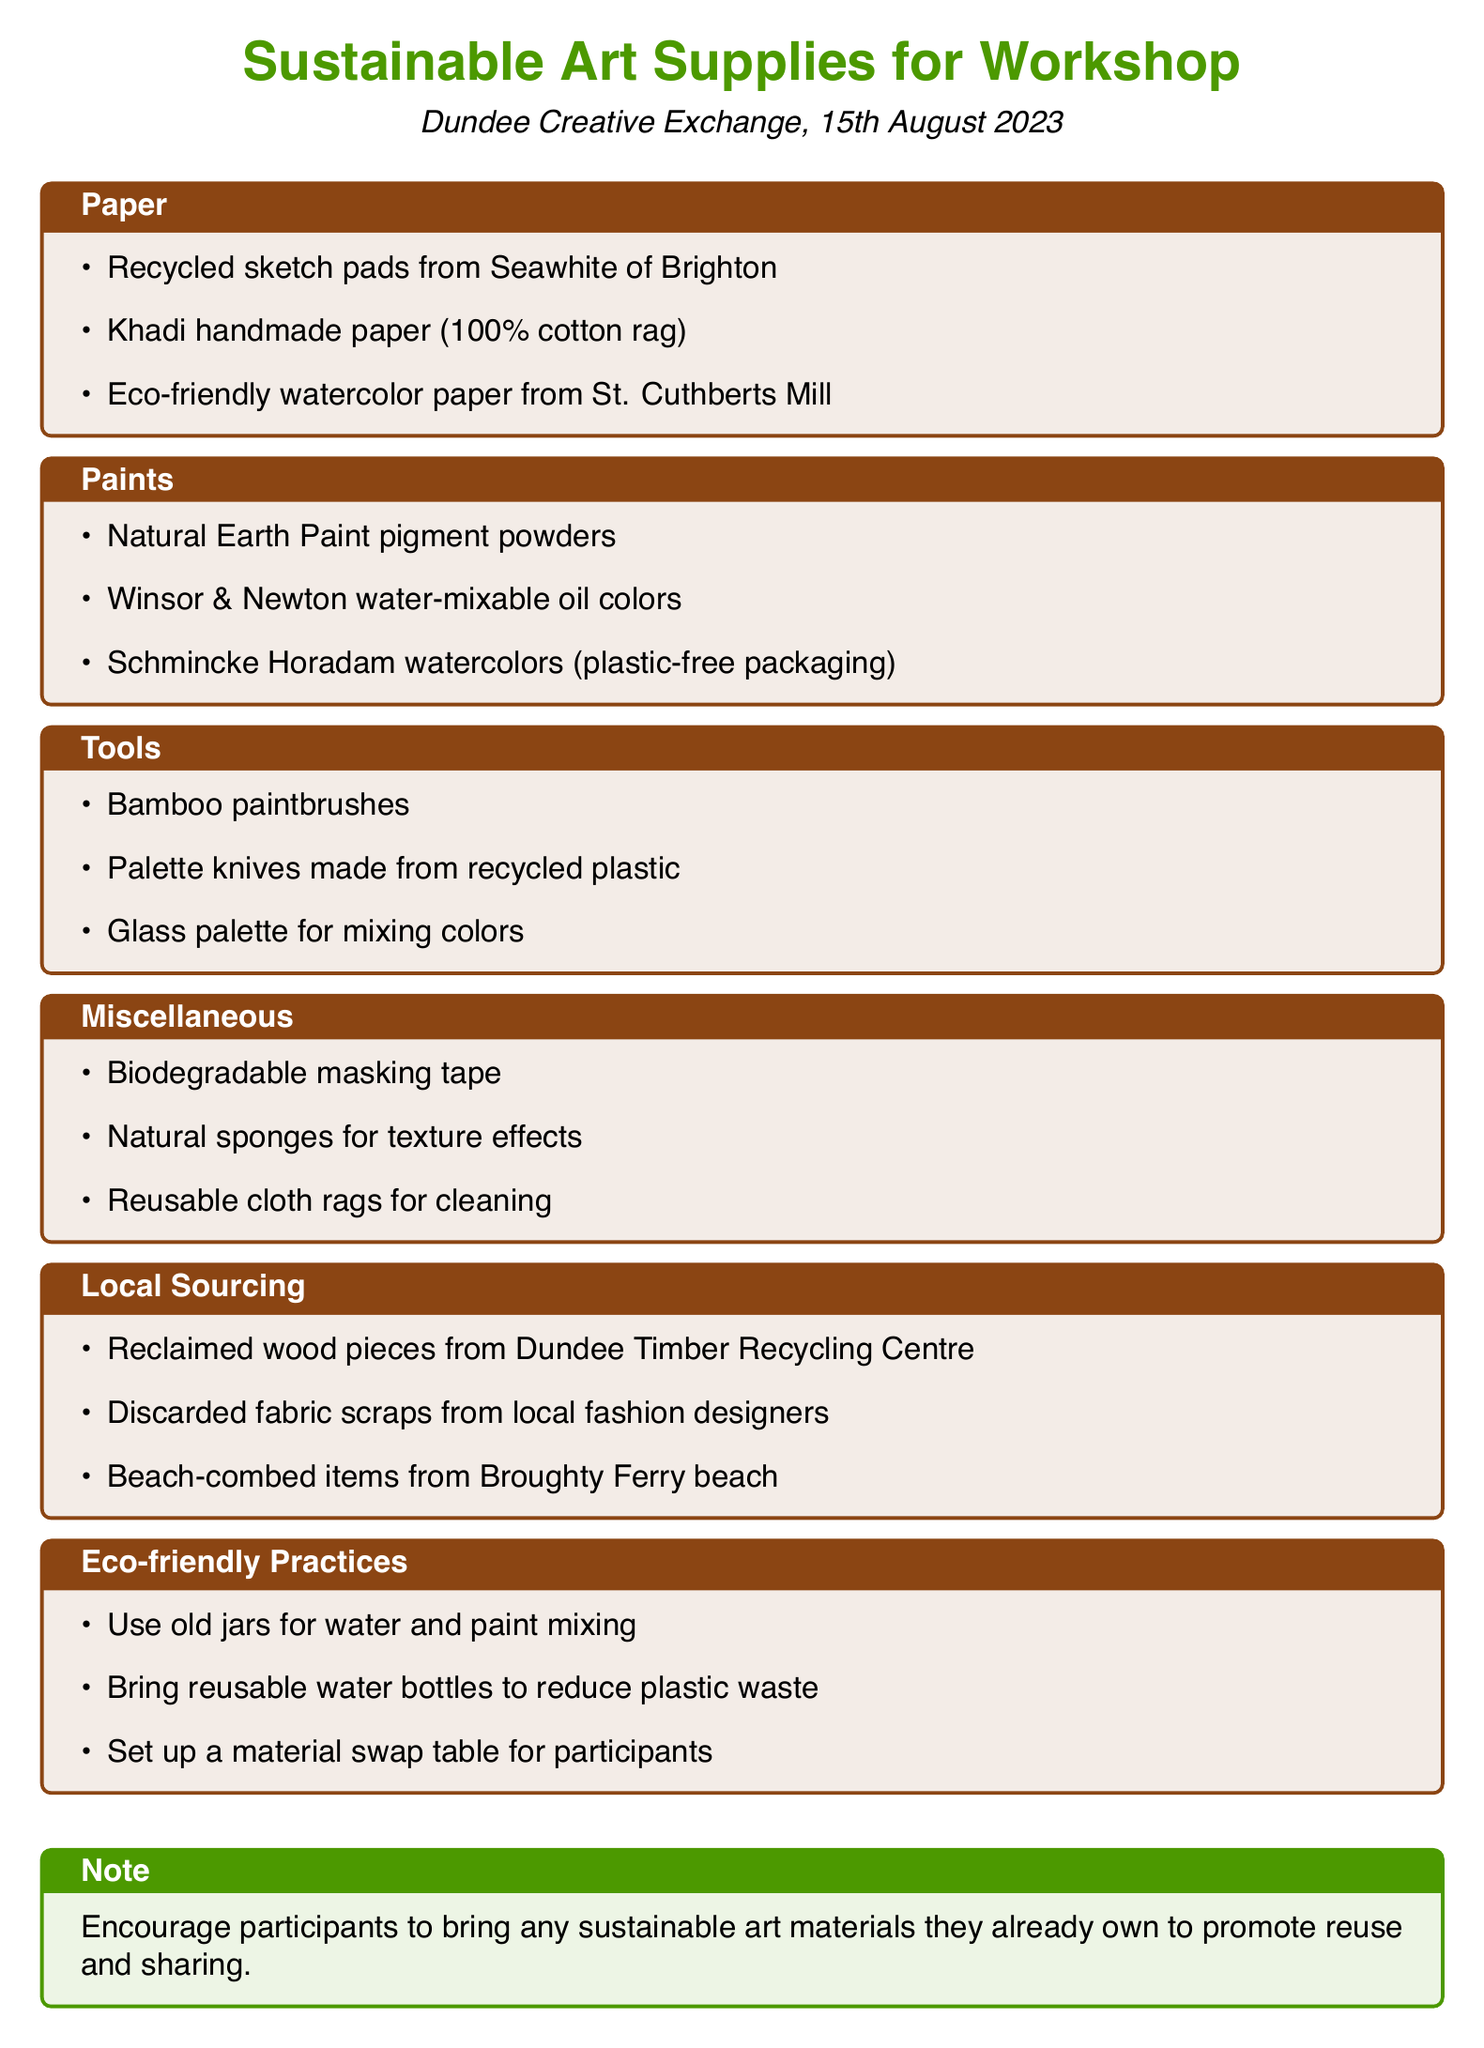What is the title of the document? The title is the first line of the document, introducing the main topic.
Answer: Sustainable Art Supplies for Workshop Where is the workshop located? The location of the workshop is mentioned prominently in the document under the title.
Answer: Dundee Creative Exchange What date is the workshop scheduled for? The date is specified in the introduction of the document, indicating when the event will take place.
Answer: 15th August 2023 What type of paint is mentioned that comes in plastic-free packaging? This is a specific detail found in the paints category where unique features of art supplies are highlighted.
Answer: Schmincke Horadam watercolors Which item is sourced locally from the Dundee Timber Recycling Centre? This requires an understanding of the local sourcing section, identifying supplies specifically obtained from local sources.
Answer: Reclaimed wood pieces What eco-friendly practice encourages reducing plastic waste? This question connects the practices suggested in the document related to sustainability with an emphasis on minimizing plastic usage.
Answer: Bring reusable water bottles to reduce plastic waste How many categories of supplies are listed in the document? This entails counting the distinct supply categories presented throughout the document.
Answer: Six Name one type of biodegradable item mentioned in the miscellaneous category. The question seeks specific examples from the miscellaneous supplies listed.
Answer: Biodegradable masking tape What is the note at the end of the document encouraging participants to bring? It refers to the suggestion aimed at promoting participation and sharing during the workshop.
Answer: Sustainable art materials they already own to promote reuse and sharing 